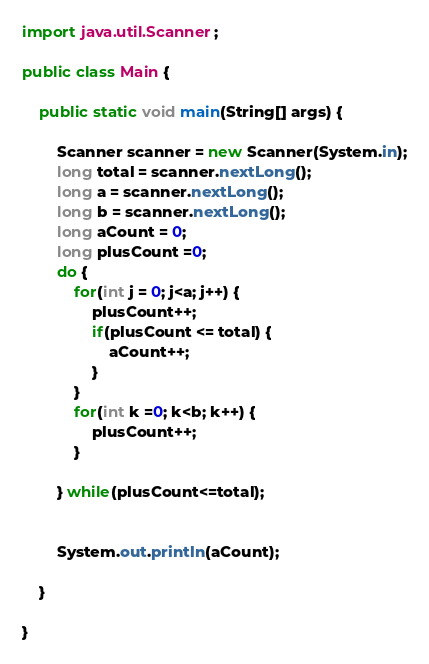Convert code to text. <code><loc_0><loc_0><loc_500><loc_500><_Java_>import java.util.Scanner;

public class Main {
	
	public static void main(String[] args) {
		
		Scanner scanner = new Scanner(System.in);
		long total = scanner.nextLong();
		long a = scanner.nextLong();
		long b = scanner.nextLong();
		long aCount = 0;
		long plusCount =0;
		do {
			for(int j = 0; j<a; j++) {
				plusCount++;
				if(plusCount <= total) {
					aCount++;
				}
			}
			for(int k =0; k<b; k++) {
				plusCount++;
			}
			
		} while(plusCount<=total);
		
		
		System.out.println(aCount);

	}	
	
}</code> 